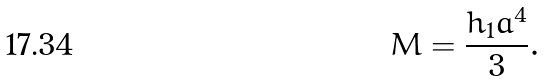<formula> <loc_0><loc_0><loc_500><loc_500>M = \frac { h _ { 1 } a ^ { 4 } } { 3 } .</formula> 